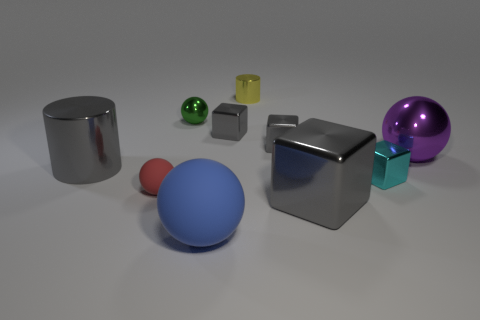Is the cyan object the same shape as the red rubber object?
Make the answer very short. No. What color is the small shiny cylinder?
Ensure brevity in your answer.  Yellow. What number of other things are the same material as the large purple object?
Provide a succinct answer. 7. How many blue things are either cubes or large things?
Your answer should be compact. 1. Is the shape of the small metallic object in front of the big metallic ball the same as the rubber object in front of the small matte ball?
Make the answer very short. No. There is a big rubber sphere; does it have the same color as the small ball in front of the gray cylinder?
Your answer should be very brief. No. There is a small shiny cube to the left of the yellow metallic object; is it the same color as the big cylinder?
Offer a terse response. Yes. What number of objects are either small yellow matte balls or big things that are right of the small red ball?
Offer a very short reply. 3. What material is the cube that is behind the tiny red object and in front of the large purple shiny thing?
Offer a very short reply. Metal. What is the material of the block in front of the red matte thing?
Offer a terse response. Metal. 